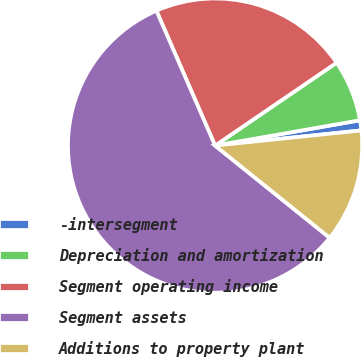<chart> <loc_0><loc_0><loc_500><loc_500><pie_chart><fcel>-intersegment<fcel>Depreciation and amortization<fcel>Segment operating income<fcel>Segment assets<fcel>Additions to property plant<nl><fcel>1.11%<fcel>6.77%<fcel>22.01%<fcel>57.69%<fcel>12.43%<nl></chart> 